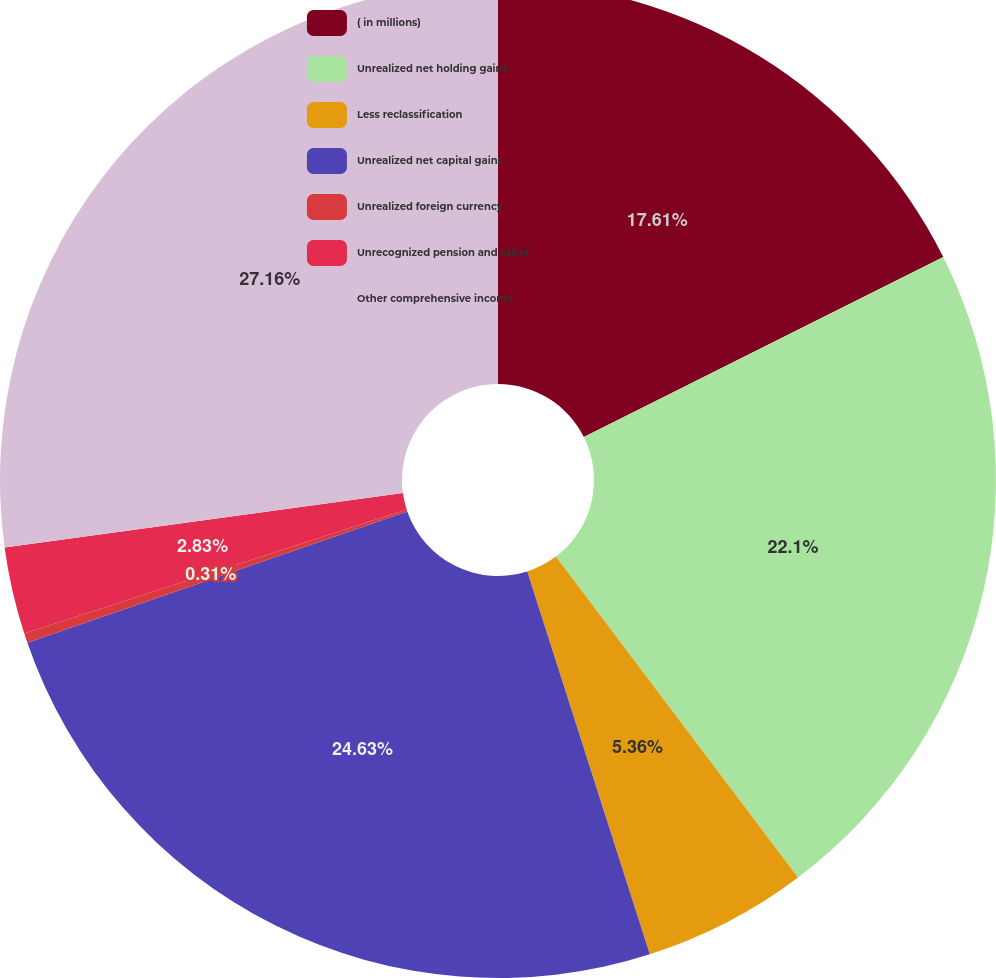Convert chart. <chart><loc_0><loc_0><loc_500><loc_500><pie_chart><fcel>( in millions)<fcel>Unrealized net holding gains<fcel>Less reclassification<fcel>Unrealized net capital gains<fcel>Unrealized foreign currency<fcel>Unrecognized pension and other<fcel>Other comprehensive income<nl><fcel>17.61%<fcel>22.1%<fcel>5.36%<fcel>24.63%<fcel>0.31%<fcel>2.83%<fcel>27.16%<nl></chart> 